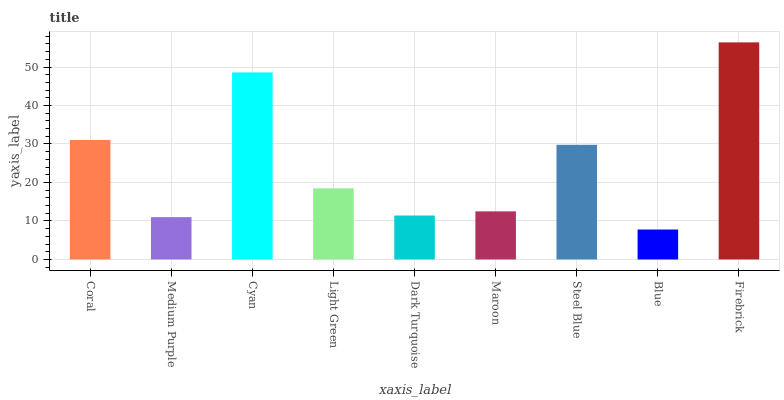Is Blue the minimum?
Answer yes or no. Yes. Is Firebrick the maximum?
Answer yes or no. Yes. Is Medium Purple the minimum?
Answer yes or no. No. Is Medium Purple the maximum?
Answer yes or no. No. Is Coral greater than Medium Purple?
Answer yes or no. Yes. Is Medium Purple less than Coral?
Answer yes or no. Yes. Is Medium Purple greater than Coral?
Answer yes or no. No. Is Coral less than Medium Purple?
Answer yes or no. No. Is Light Green the high median?
Answer yes or no. Yes. Is Light Green the low median?
Answer yes or no. Yes. Is Steel Blue the high median?
Answer yes or no. No. Is Blue the low median?
Answer yes or no. No. 